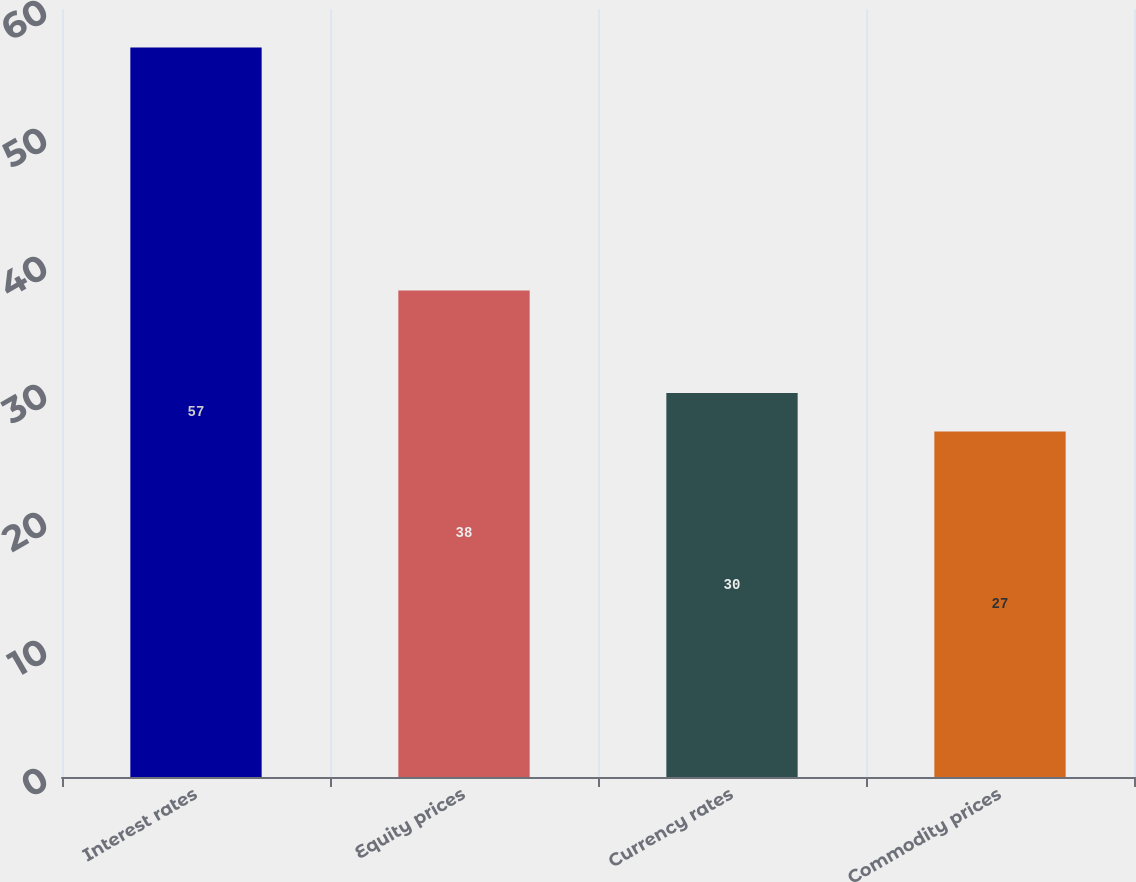<chart> <loc_0><loc_0><loc_500><loc_500><bar_chart><fcel>Interest rates<fcel>Equity prices<fcel>Currency rates<fcel>Commodity prices<nl><fcel>57<fcel>38<fcel>30<fcel>27<nl></chart> 